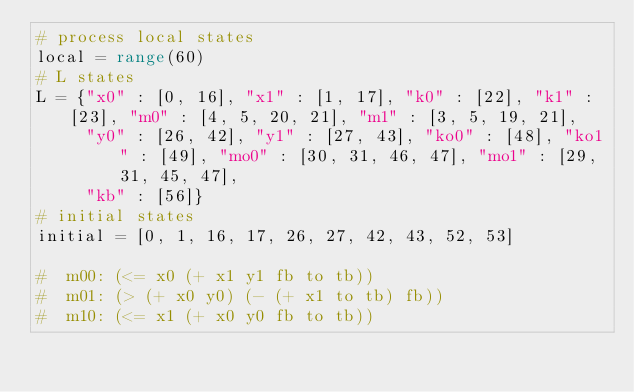Convert code to text. <code><loc_0><loc_0><loc_500><loc_500><_Python_># process local states
local = range(60)
# L states
L = {"x0" : [0, 16], "x1" : [1, 17], "k0" : [22], "k1" : [23], "m0" : [4, 5, 20, 21], "m1" : [3, 5, 19, 21],
     "y0" : [26, 42], "y1" : [27, 43], "ko0" : [48], "ko1" : [49], "mo0" : [30, 31, 46, 47], "mo1" : [29, 31, 45, 47],
     "kb" : [56]}
# initial states
initial = [0, 1, 16, 17, 26, 27, 42, 43, 52, 53]

#  m00: (<= x0 (+ x1 y1 fb to tb))
#  m01: (> (+ x0 y0) (- (+ x1 to tb) fb))
#  m10: (<= x1 (+ x0 y0 fb to tb))</code> 